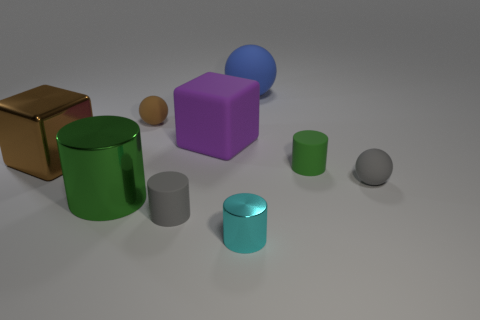Are there fewer cyan cylinders than big purple cylinders?
Ensure brevity in your answer.  No. How many things are either green matte objects or cylinders behind the big metallic cylinder?
Ensure brevity in your answer.  1. Are there any brown balls made of the same material as the large purple block?
Make the answer very short. Yes. There is a green cylinder that is the same size as the brown cube; what is its material?
Give a very brief answer. Metal. There is a large brown cube that is left of the brown object that is behind the brown metallic cube; what is its material?
Offer a very short reply. Metal. There is a gray rubber object that is left of the tiny cyan metallic cylinder; does it have the same shape as the small green thing?
Your answer should be very brief. Yes. What is the color of the big thing that is the same material as the blue ball?
Provide a short and direct response. Purple. There is a green cylinder that is behind the gray ball; what is it made of?
Make the answer very short. Rubber. Is the shape of the tiny green matte object the same as the tiny gray object on the right side of the cyan metal thing?
Ensure brevity in your answer.  No. There is a ball that is both in front of the big rubber sphere and left of the small green rubber thing; what is its material?
Provide a succinct answer. Rubber. 